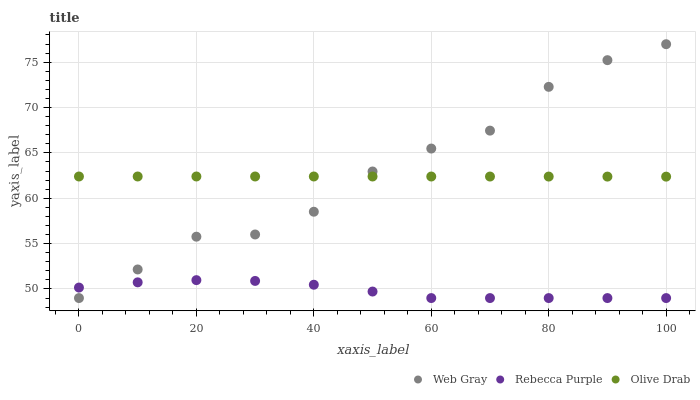Does Rebecca Purple have the minimum area under the curve?
Answer yes or no. Yes. Does Web Gray have the maximum area under the curve?
Answer yes or no. Yes. Does Olive Drab have the minimum area under the curve?
Answer yes or no. No. Does Olive Drab have the maximum area under the curve?
Answer yes or no. No. Is Olive Drab the smoothest?
Answer yes or no. Yes. Is Web Gray the roughest?
Answer yes or no. Yes. Is Rebecca Purple the smoothest?
Answer yes or no. No. Is Rebecca Purple the roughest?
Answer yes or no. No. Does Web Gray have the lowest value?
Answer yes or no. Yes. Does Olive Drab have the lowest value?
Answer yes or no. No. Does Web Gray have the highest value?
Answer yes or no. Yes. Does Olive Drab have the highest value?
Answer yes or no. No. Is Rebecca Purple less than Olive Drab?
Answer yes or no. Yes. Is Olive Drab greater than Rebecca Purple?
Answer yes or no. Yes. Does Web Gray intersect Rebecca Purple?
Answer yes or no. Yes. Is Web Gray less than Rebecca Purple?
Answer yes or no. No. Is Web Gray greater than Rebecca Purple?
Answer yes or no. No. Does Rebecca Purple intersect Olive Drab?
Answer yes or no. No. 